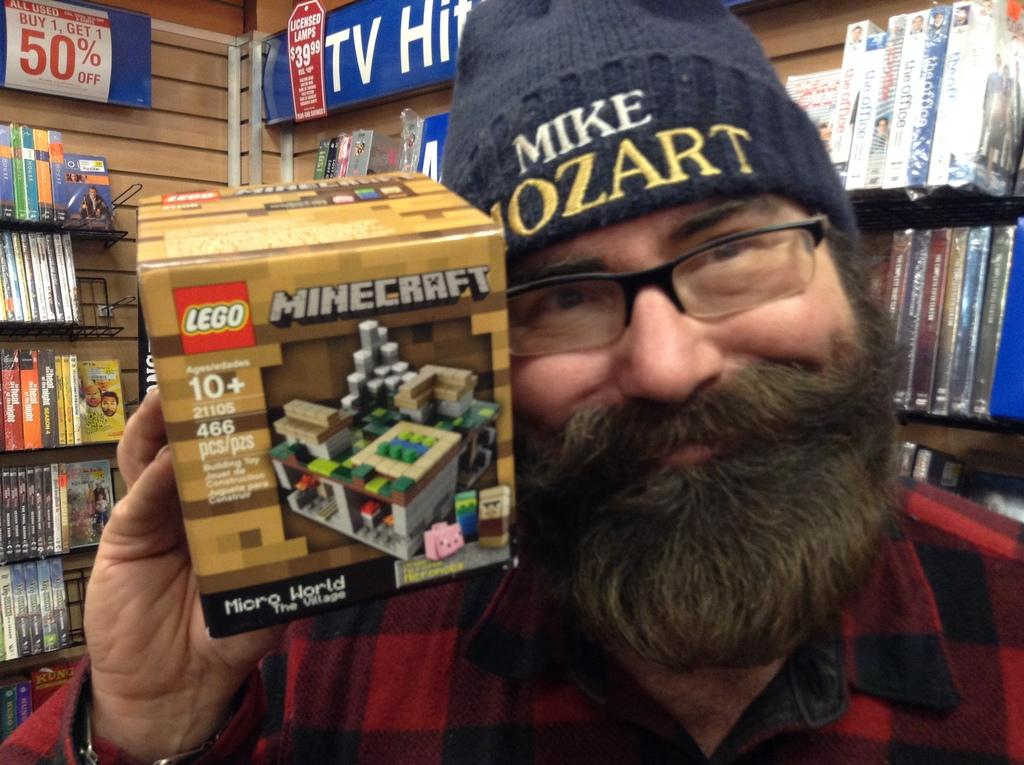Who is present in the image? There is a man in the image. What is the man doing in the image? The man is smiling in the image. What is the man wearing on his upper body? The man is wearing a red color shirt in the image. What accessory is the man wearing on his face? The man is wearing spectacles in the image. What headgear is the man wearing? The man is wearing a cap in the image. What object is the man holding in his hand? The man is holding a box in his hand in the image. What can be seen behind the man? There are books and a poster behind the man in the image. Can you see any mountains in the image? There are no mountains present in the image. What type of seed is the man planting in the image? There is no seed or planting activity depicted in the image. 